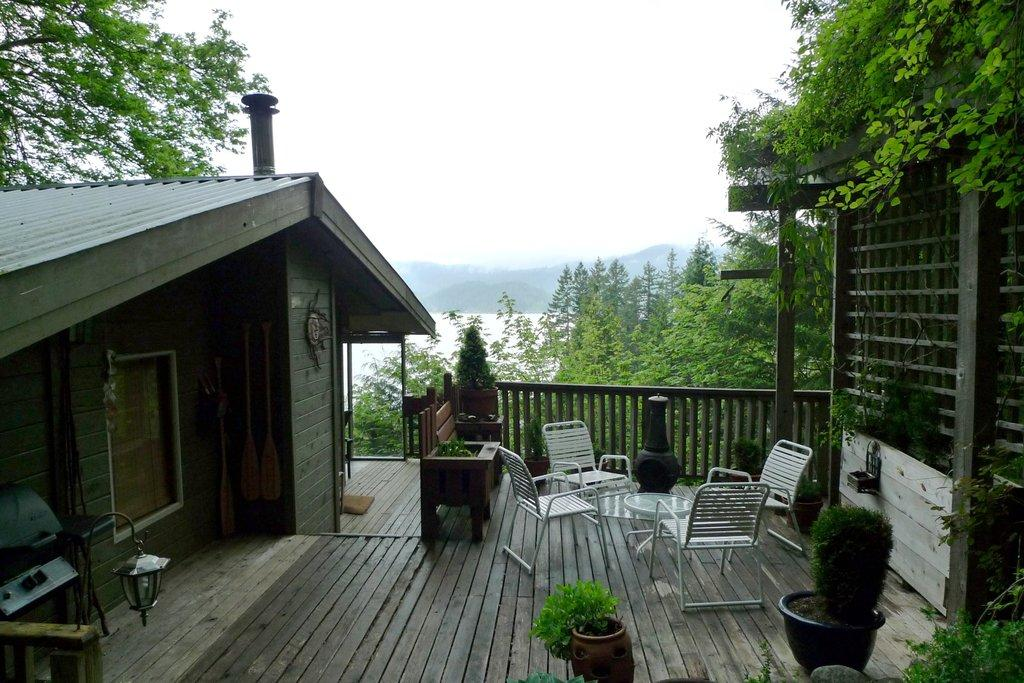What type of structure is present in the image? There is a house in the image. Can you describe the lighting conditions in the image? There is light visible in the image. What type of vegetation can be seen in the image? There are plants and trees in the image. What type of furniture is present in the image? There are chairs in the image. What natural element is visible in the image? There is water visible in the image. What type of amusement can be seen in the image? There is no amusement present in the image; it features a house, light, plants, trees, chairs, and water. What type of stone is visible in the image? There is no stone visible in the image. 